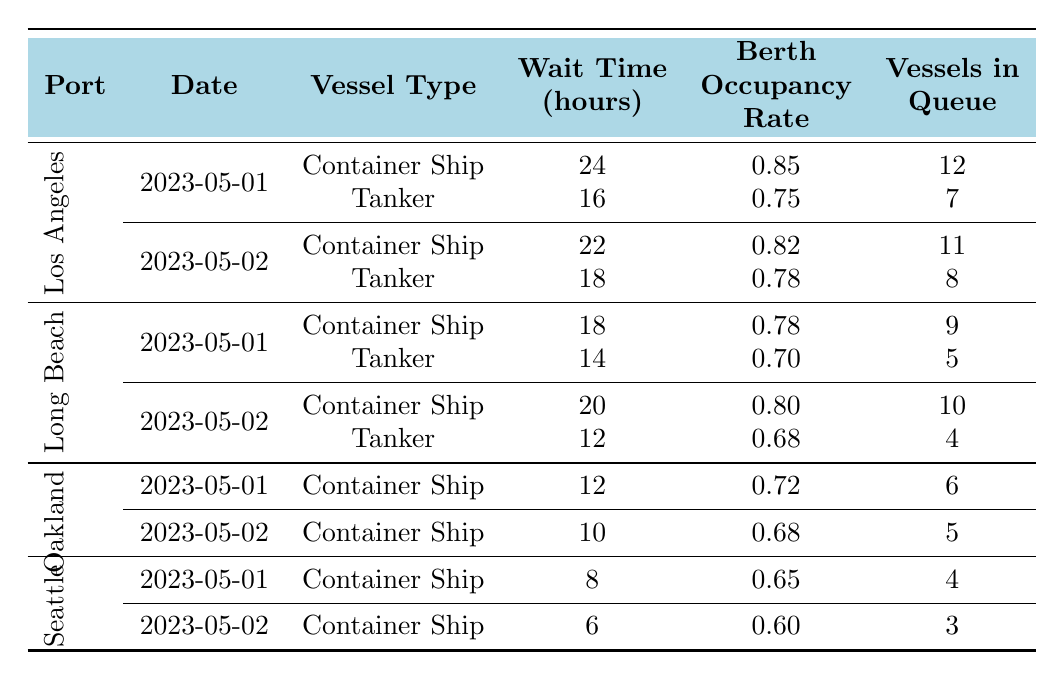What is the wait time for Container Ships at the Port of Los Angeles on May 1, 2023? The table shows the wait time for Container Ships at the Port of Los Angeles on May 1, 2023, is listed in the corresponding row. It indicates a wait time of 24 hours.
Answer: 24 hours What is the berth occupancy rate for Tankers at the Port of Long Beach on May 2, 2023? By examining the row for Tankers at the Port of Long Beach for the date May 2, 2023, I can see that the berth occupancy rate is 0.68.
Answer: 0.68 Which port had the highest average wait time for Container Ships over the two days? First, I will look at the wait times for Container Ships for May 1 and May 2 for each port. Port of Los Angeles: (24 + 22)/2 = 23, Port of Long Beach: (18 + 20)/2 = 19, Port of Oakland: (12 + 10)/2 = 11, Port of Seattle: (8 + 6)/2 = 7. The highest average is 23 at the Port of Los Angeles.
Answer: Port of Los Angeles Is the wait time for Tankers lower in the Port of Long Beach on May 1 than in the Port of Los Angeles on the same day? The wait time for Tankers in the Port of Long Beach on May 1 is 14 hours, while in the Port of Los Angeles, it is 16 hours. Since 14 is less than 16, the statement is true.
Answer: Yes What is the total number of vessels in queue for Container Ships across all ports on May 2, 2023? To find the total vessels in queue on May 2, I will sum the values from the relevant rows: Port of Los Angeles (11) + Port of Long Beach (10) + Port of Oakland (5) + Port of Seattle (3) = 29.
Answer: 29 Was the berth occupancy rate for Container Ships at the Port of Seattle on May 1 higher than 0.70? Looking at the table, the berth occupancy rate for Container Ships at the Port of Seattle on May 1 is 0.65, which is lower than 0.70.
Answer: No What is the difference in wait time for Container Ships between the Port of Los Angeles and the Port of Oakland on May 1, 2023? The wait time for Container Ships on May 1 at the Port of Los Angeles is 24 hours, and at the Port of Oakland, it is 12 hours. The difference is 24 - 12 = 12 hours.
Answer: 12 hours Which port had more vessels in queue for Tankers on May 2, 2023, and what was that number? I will examine the relevant rows for Tankers on May 2. The Port of Los Angeles has 8 vessels in queue while the Port of Long Beach has 4. The Port of Los Angeles has more vessels in queue.
Answer: Port of Los Angeles, 8 vessels What is the overall average berth occupancy rate for Container Ships at the Port of Long Beach across the two days? The berth occupancy rates for Container Ships at the Port of Long Beach on the two days are 0.78 and 0.80. The average rate is (0.78 + 0.80) / 2 = 0.79.
Answer: 0.79 